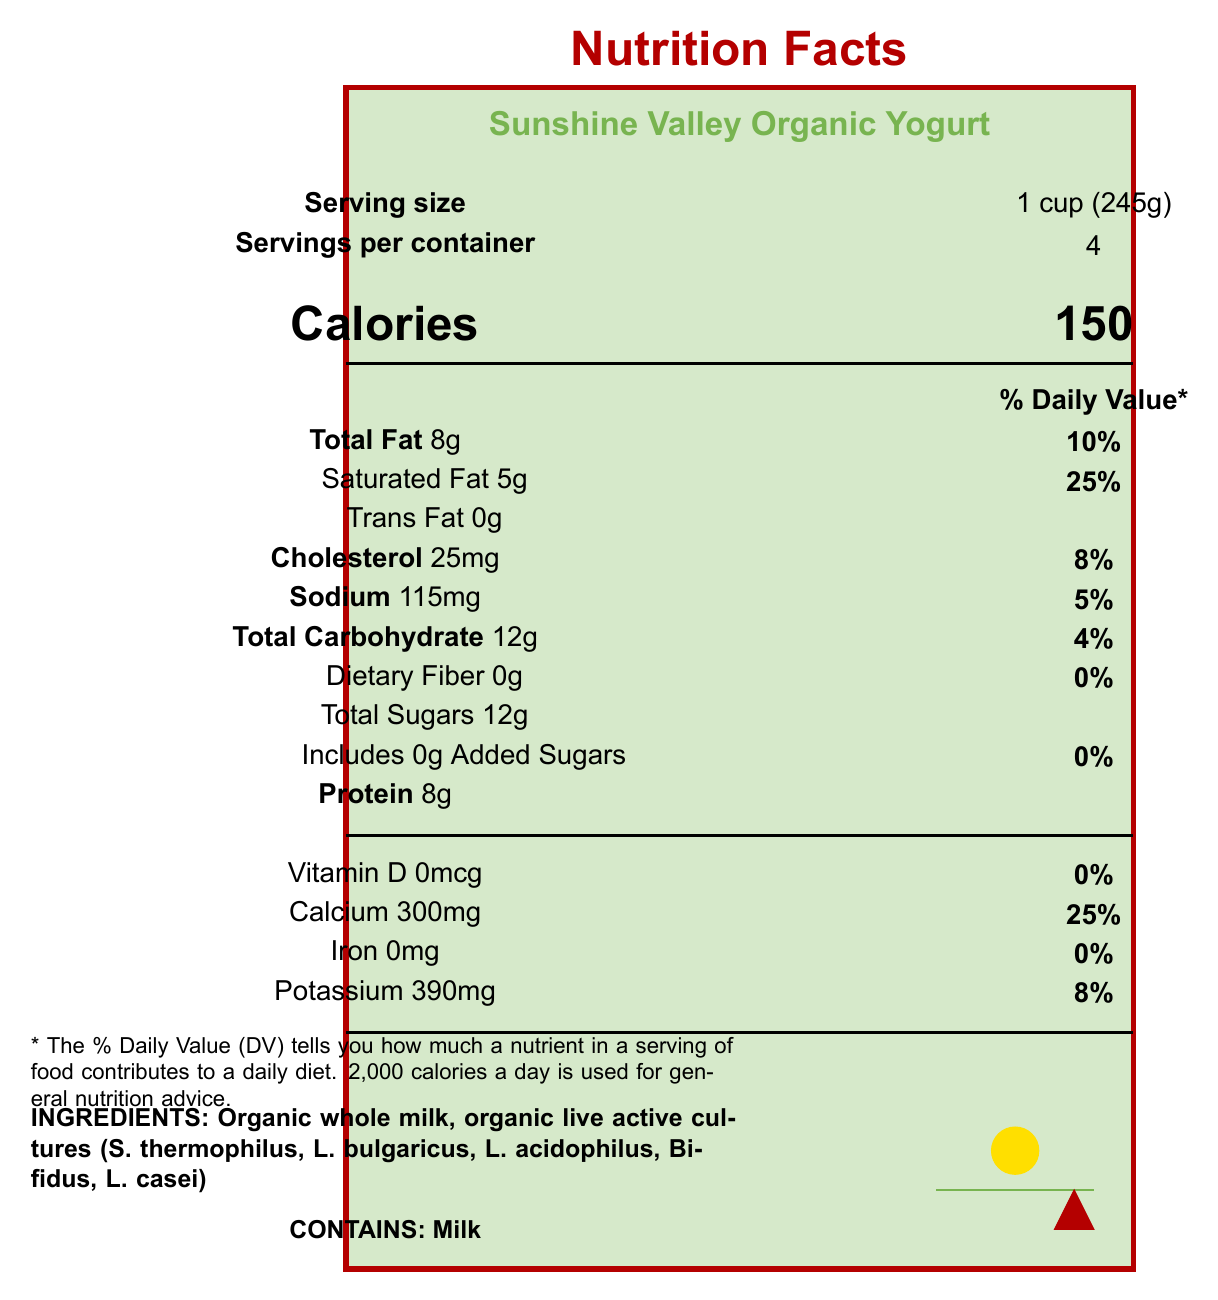what is the serving size? The serving size is clearly listed as "1 cup (245g)" in the serving information section at the top of the document.
Answer: 1 cup (245g) how many servings are in the container? The document states there are 4 servings per container, located right below the serving size information.
Answer: 4 how many calories are in a serving of this yogurt? The number of calories per serving is listed prominently in the document as 150.
Answer: 150 what is the total fat content per serving? The total fat per serving is given as 8g, located in the nutrient information section.
Answer: 8g how much protein is in one serving? The protein content per serving is noted as 8g, found in the nutrient details section.
Answer: 8g how much calcium does one serving provide? The calcium content is specified as 300mg per serving in the vitamin and mineral information section.
Answer: 300mg does this yogurt contain any added sugars? The document lists "Includes 0g Added Sugars," indicating there are no added sugars in this yogurt.
Answer: No which certification does the yogurt have? A. Non-GMO Project Verified B. USDA Organic C. Both A and B D. None of the above The document lists both "USDA Organic" and "Non-GMO Project Verified" certifications.
Answer: C what is the allergen information for this yogurt? A. Contains soy B. Contains milk C. Contains gluten D. Contains nuts The document clearly states in the allergen information section that it contains milk.
Answer: B is the container recyclable? The document mentions that the container is a "Recyclable plastic tub."
Answer: Yes how much of the daily value of saturated fat does a serving contain? The saturated fat content contributes to 25% of the daily value, as mentioned in the nutrient section.
Answer: 25% how much cholesterol is present per serving in this yogurt? The amount of cholesterol per serving is listed as 25mg.
Answer: 25mg what is the expiration date recommendation? The document states that the yogurt is best if used within 14 days of opening.
Answer: Best if used within 14 days of opening what are the colors in the farm imagery? The farm imagery section describes the colors as green, blue, red, and yellow.
Answer: Green, blue, red, yellow what live active cultures are included in the ingredients? The ingredients list specifies these live active cultures.
Answer: S. thermophilus, L. bulgaricus, L. acidophilus, Bifidus, L. casei is this yogurt suitable for a calcium-rich diet? (Multiple-choice) A. Yes B. No Each serving contains 300mg of calcium, which is 25% of the daily value, making it suitable for a calcium-rich diet.
Answer: A summarize the main idea of this document This summary includes the key points such as the product name, serving size, certifications, ingredients, and specific nutritional values.
Answer: The document provides detailed nutritional information for Sunshine Valley Organic Yogurt, including serving size, calories, and nutrient content. It highlights the organic and non-GMO certifications and the ingredients used. The document also includes allergen information and a description of the farm imagery. what colors are on the packaging according to the document? The document does not provide information about the colors on the packaging; it only describes the colors of the farm imagery section.
Answer: Cannot be determined does the yogurt contain artificial colors or flavors? The document includes a claim stating "No artificial colors or flavors."
Answer: No 